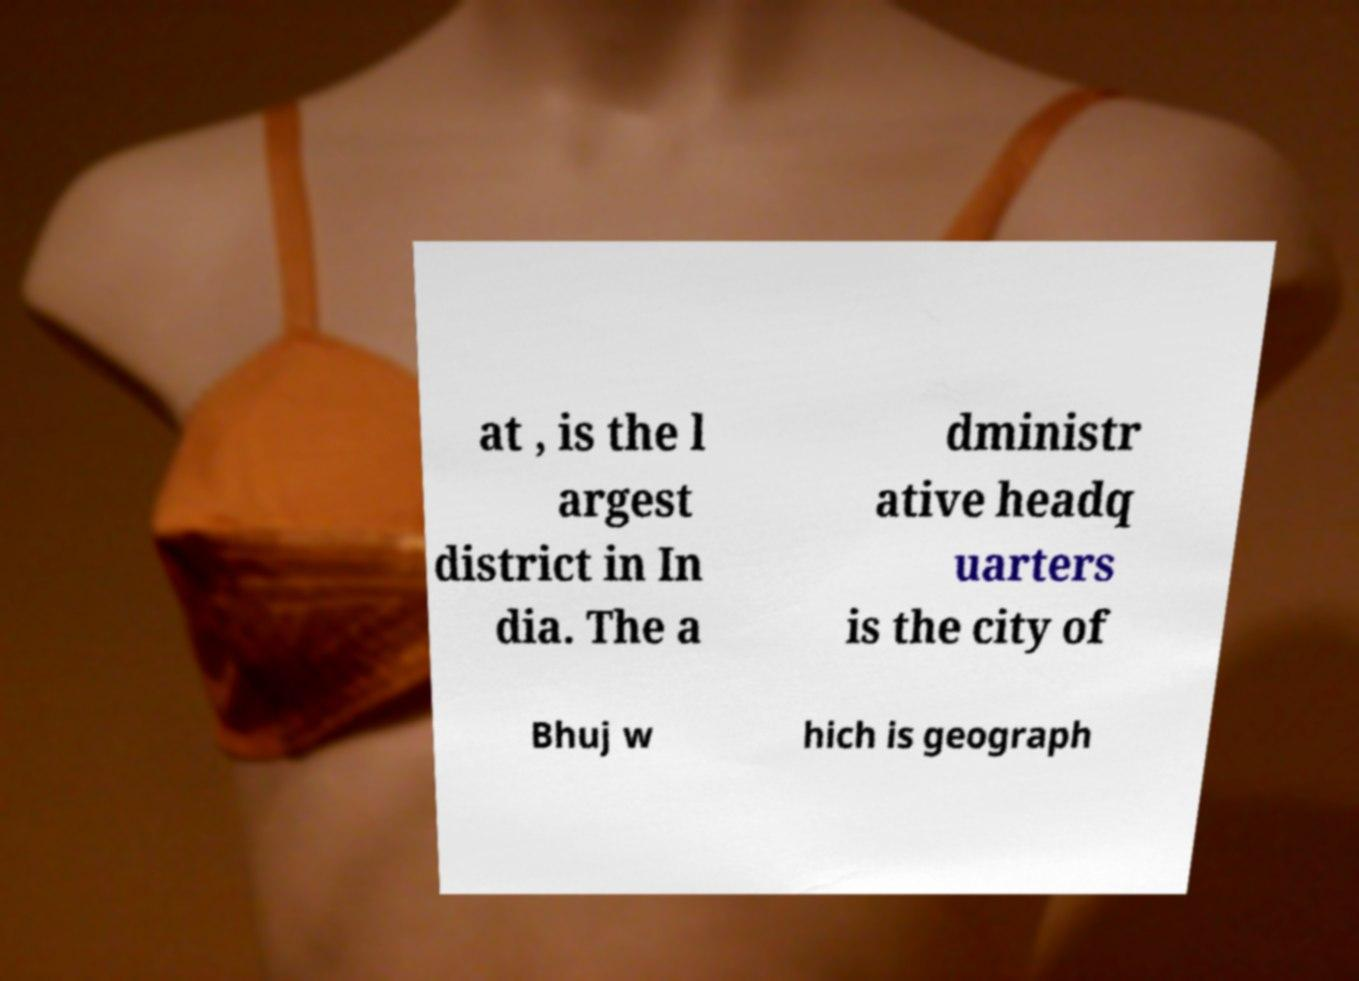Please read and relay the text visible in this image. What does it say? at , is the l argest district in In dia. The a dministr ative headq uarters is the city of Bhuj w hich is geograph 